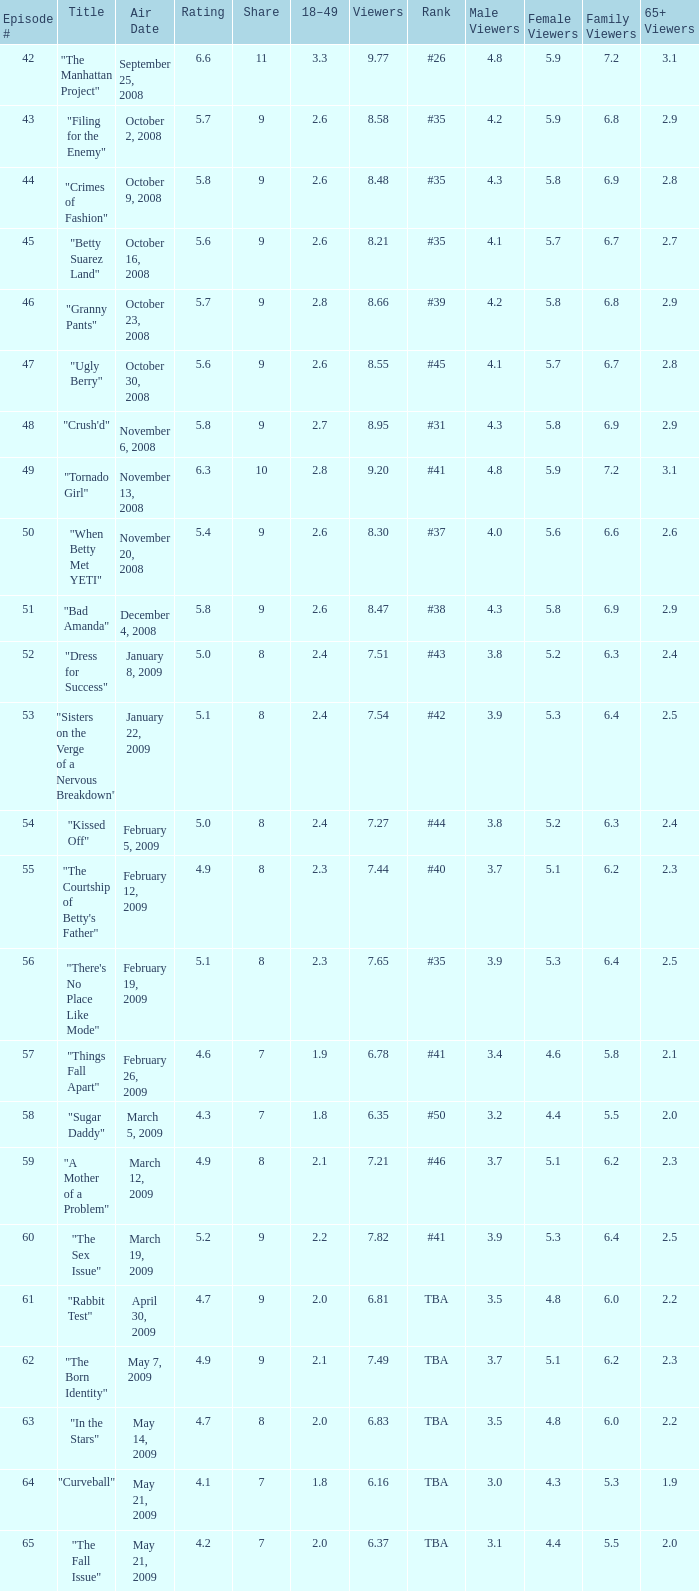What is the average Episode # with a 7 share and 18–49 is less than 2 and the Air Date of may 21, 2009? 64.0. 